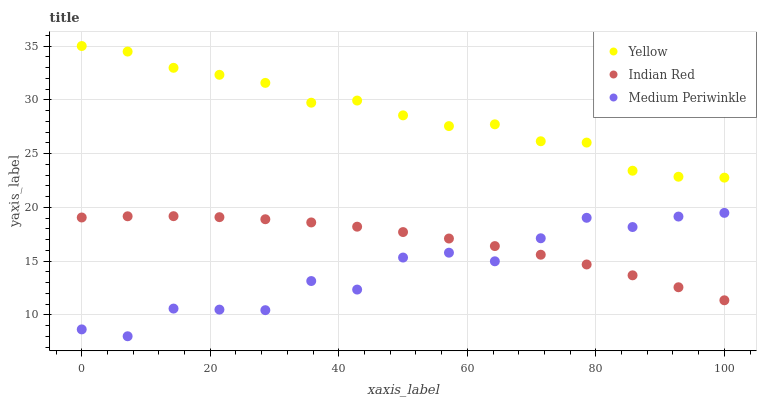Does Medium Periwinkle have the minimum area under the curve?
Answer yes or no. Yes. Does Yellow have the maximum area under the curve?
Answer yes or no. Yes. Does Indian Red have the minimum area under the curve?
Answer yes or no. No. Does Indian Red have the maximum area under the curve?
Answer yes or no. No. Is Indian Red the smoothest?
Answer yes or no. Yes. Is Medium Periwinkle the roughest?
Answer yes or no. Yes. Is Yellow the smoothest?
Answer yes or no. No. Is Yellow the roughest?
Answer yes or no. No. Does Medium Periwinkle have the lowest value?
Answer yes or no. Yes. Does Indian Red have the lowest value?
Answer yes or no. No. Does Yellow have the highest value?
Answer yes or no. Yes. Does Indian Red have the highest value?
Answer yes or no. No. Is Indian Red less than Yellow?
Answer yes or no. Yes. Is Yellow greater than Indian Red?
Answer yes or no. Yes. Does Medium Periwinkle intersect Indian Red?
Answer yes or no. Yes. Is Medium Periwinkle less than Indian Red?
Answer yes or no. No. Is Medium Periwinkle greater than Indian Red?
Answer yes or no. No. Does Indian Red intersect Yellow?
Answer yes or no. No. 